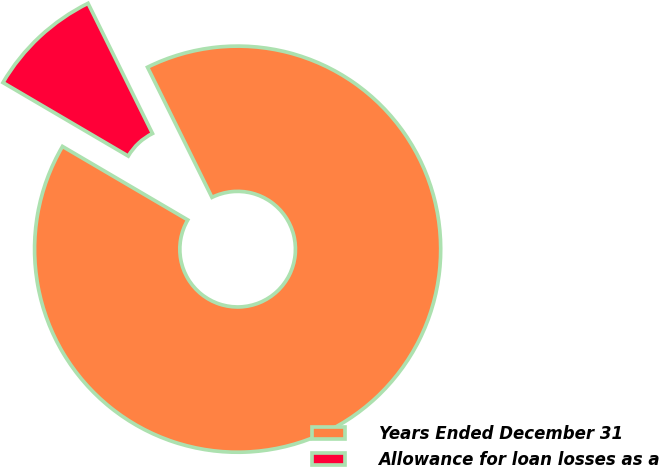<chart> <loc_0><loc_0><loc_500><loc_500><pie_chart><fcel>Years Ended December 31<fcel>Allowance for loan losses as a<nl><fcel>90.76%<fcel>9.24%<nl></chart> 